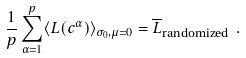Convert formula to latex. <formula><loc_0><loc_0><loc_500><loc_500>\frac { 1 } { p } \sum _ { \alpha = 1 } ^ { p } \langle L ( { c } ^ { \alpha } ) \rangle _ { \sigma _ { 0 } , \mu = 0 } = \overline { L } _ { \text {randomized} } \ .</formula> 